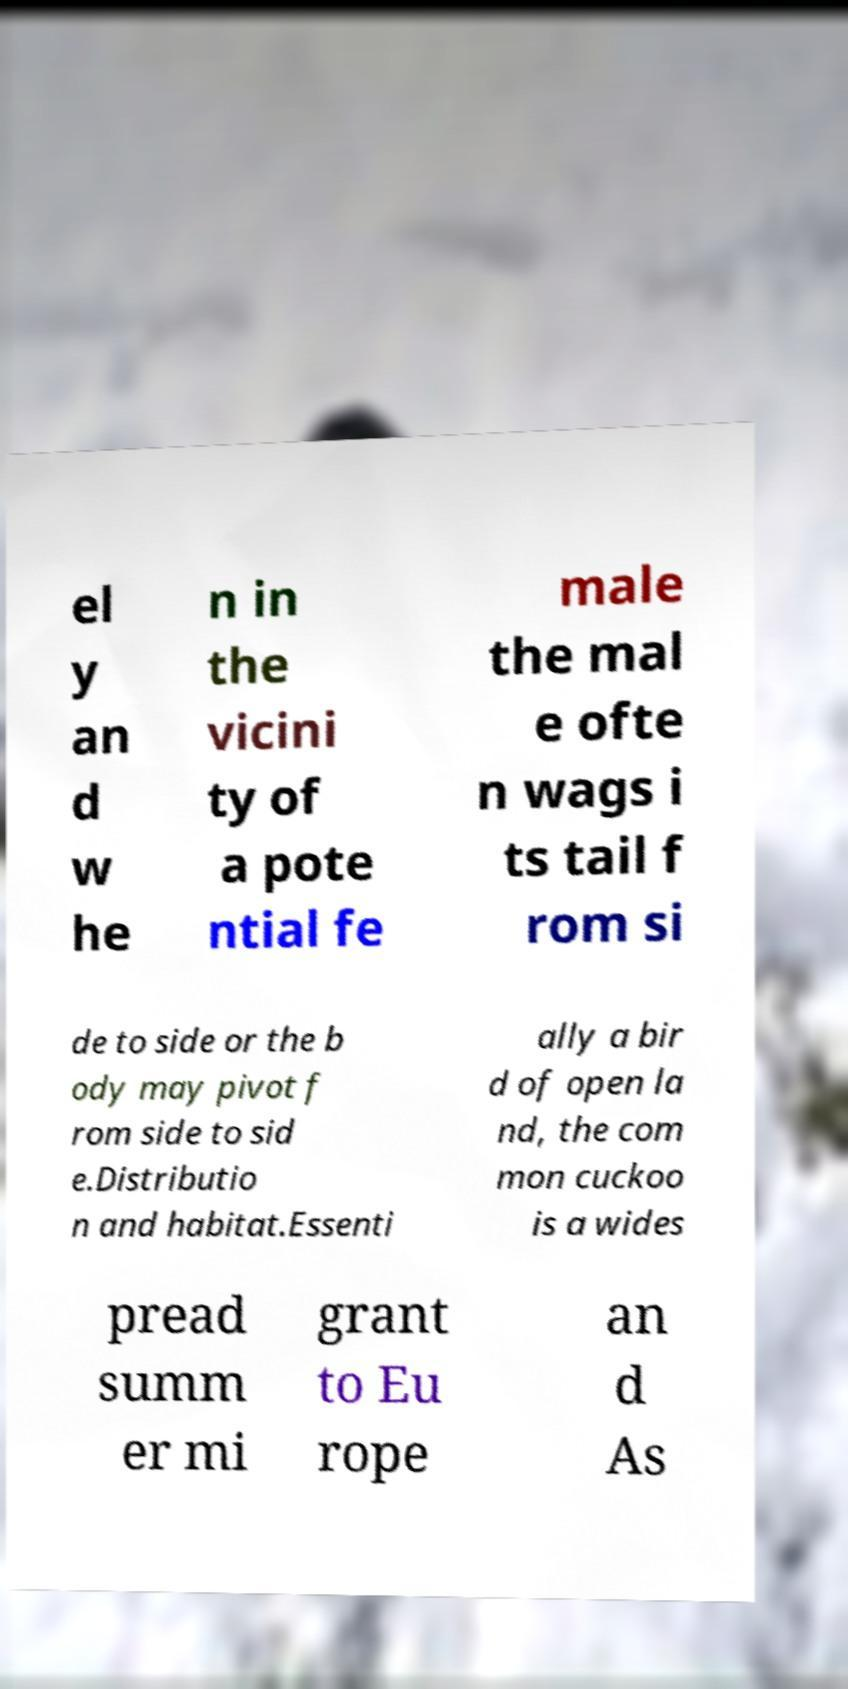Could you assist in decoding the text presented in this image and type it out clearly? el y an d w he n in the vicini ty of a pote ntial fe male the mal e ofte n wags i ts tail f rom si de to side or the b ody may pivot f rom side to sid e.Distributio n and habitat.Essenti ally a bir d of open la nd, the com mon cuckoo is a wides pread summ er mi grant to Eu rope an d As 